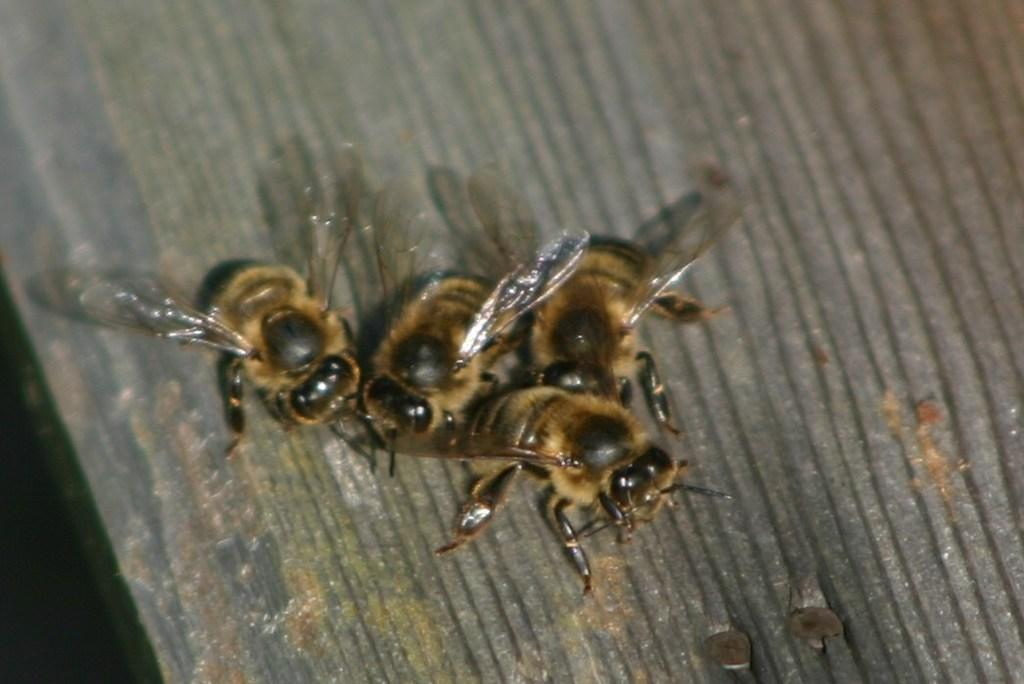How many bees can be seen in the image? There are four bees in the image. What colors are the bees? The bees are brown and black in color. What is the color of the surface the bees are on? The bees are on an ash-colored surface. Are there any other objects on the surface besides the bees? Yes, there are two nails on the surface. What type of caption is written on the image? There is no caption present in the image. What kind of apparatus is being used by the bees in the image? The bees are not using any apparatus in the image; they are simply on the surface. 